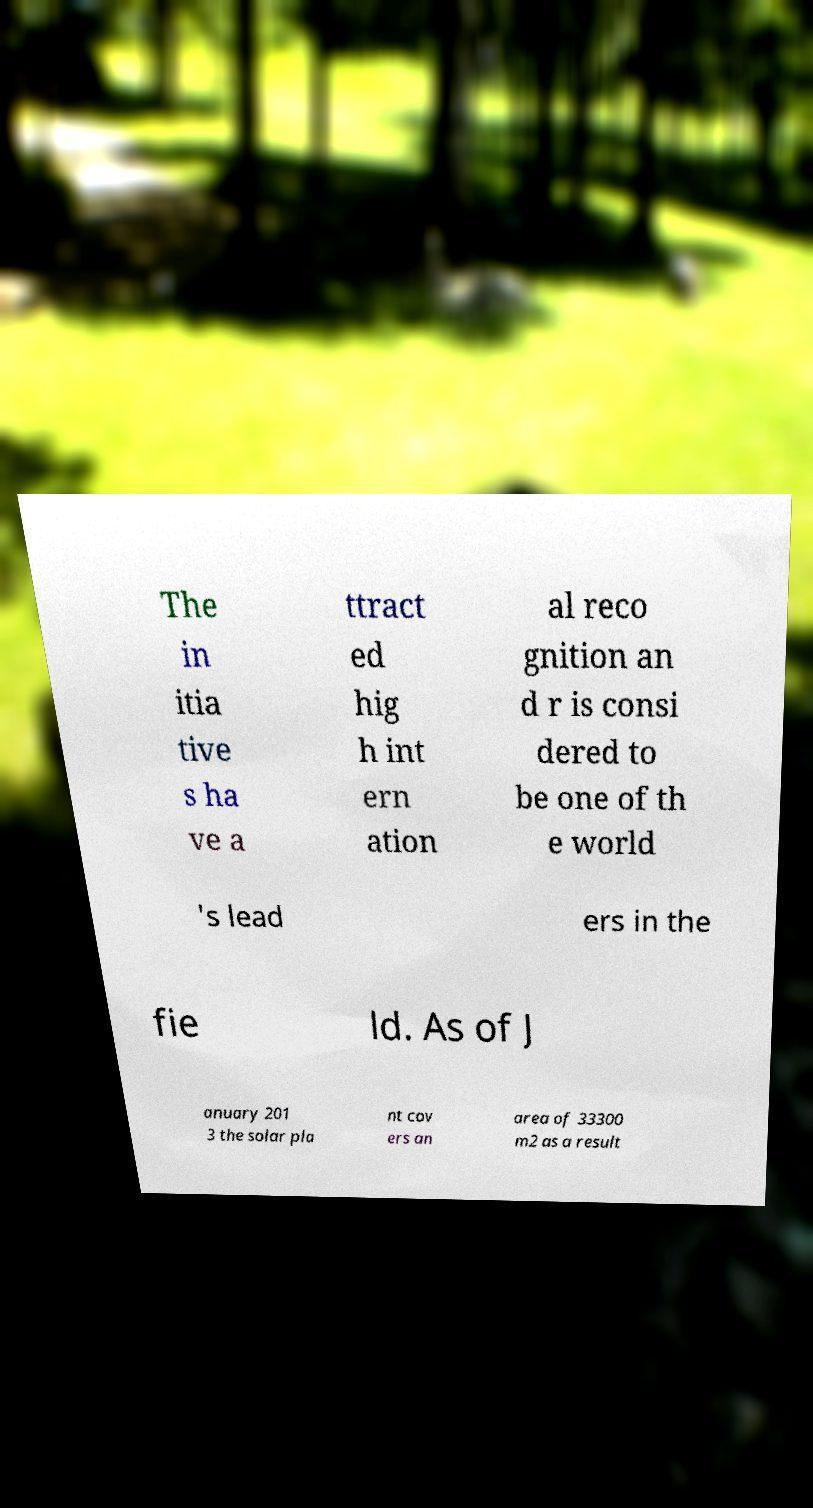I need the written content from this picture converted into text. Can you do that? The in itia tive s ha ve a ttract ed hig h int ern ation al reco gnition an d r is consi dered to be one of th e world 's lead ers in the fie ld. As of J anuary 201 3 the solar pla nt cov ers an area of 33300 m2 as a result 